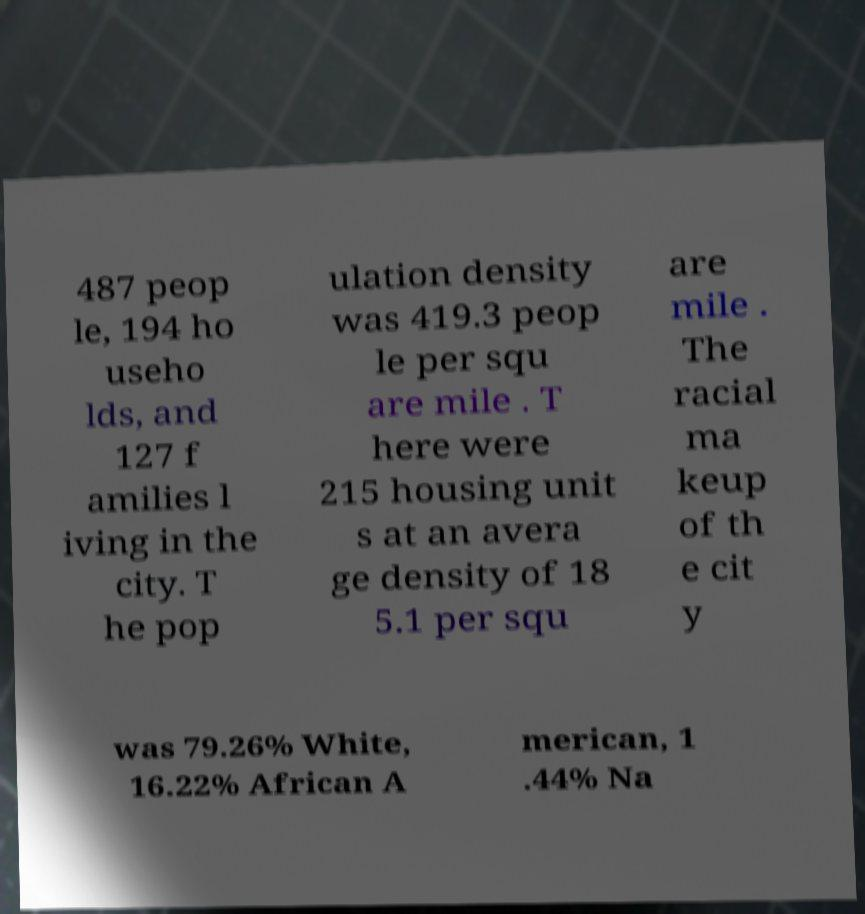Please read and relay the text visible in this image. What does it say? 487 peop le, 194 ho useho lds, and 127 f amilies l iving in the city. T he pop ulation density was 419.3 peop le per squ are mile . T here were 215 housing unit s at an avera ge density of 18 5.1 per squ are mile . The racial ma keup of th e cit y was 79.26% White, 16.22% African A merican, 1 .44% Na 